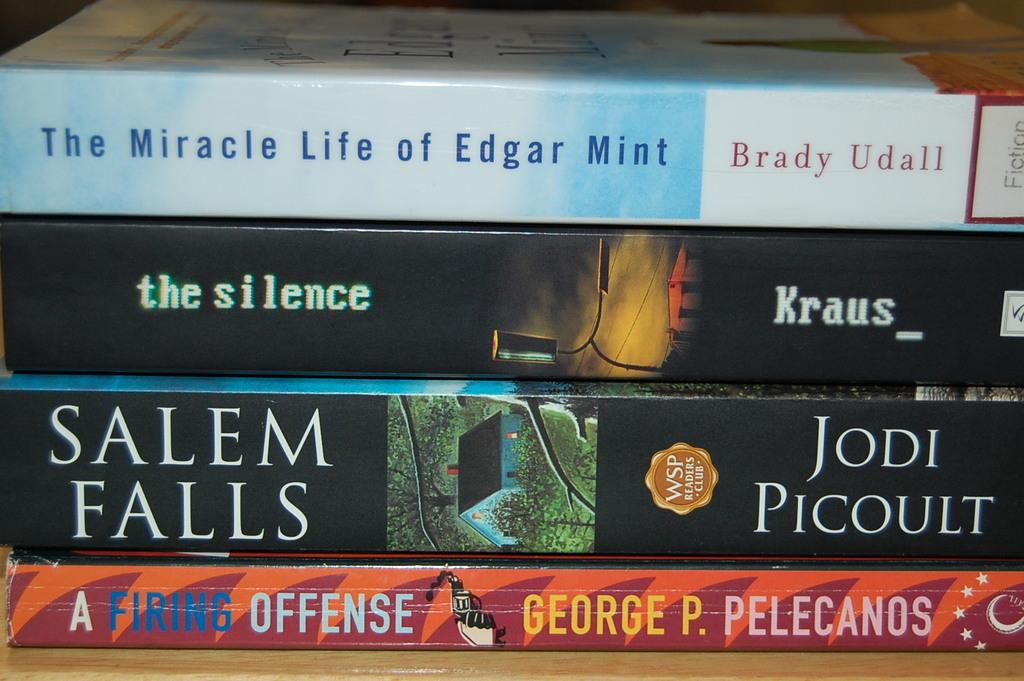<image>
Summarize the visual content of the image. Four paperback books are stacks, one by Brady Udall on top. 